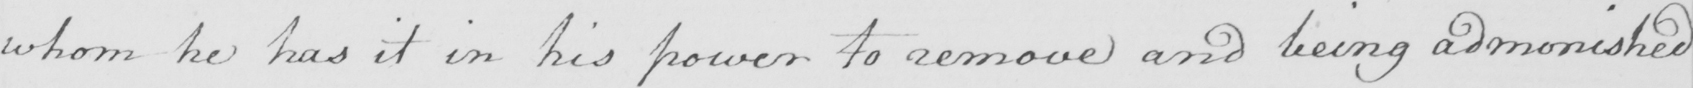Can you tell me what this handwritten text says? whom he has it in his power to remove and being admonished 